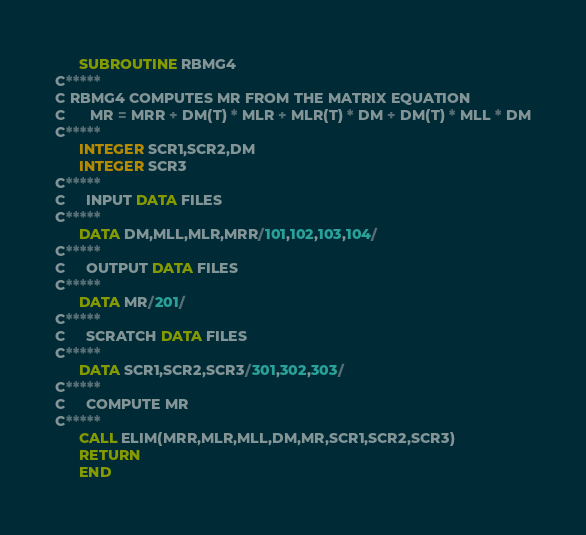<code> <loc_0><loc_0><loc_500><loc_500><_FORTRAN_>      SUBROUTINE RBMG4
C*****
C RBMG4 COMPUTES MR FROM THE MATRIX EQUATION
C      MR = MRR + DM(T) * MLR + MLR(T) * DM + DM(T) * MLL * DM
C*****
      INTEGER SCR1,SCR2,DM
      INTEGER SCR3
C*****
C     INPUT DATA FILES
C*****
      DATA DM,MLL,MLR,MRR/101,102,103,104/
C*****
C     OUTPUT DATA FILES
C*****
      DATA MR/201/
C*****
C     SCRATCH DATA FILES
C*****
      DATA SCR1,SCR2,SCR3/301,302,303/
C*****
C     COMPUTE MR
C*****
      CALL ELIM(MRR,MLR,MLL,DM,MR,SCR1,SCR2,SCR3)
      RETURN
      END
</code> 